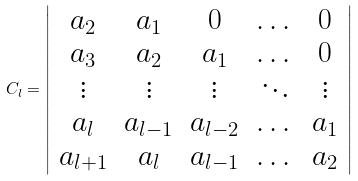<formula> <loc_0><loc_0><loc_500><loc_500>C _ { l } = \left | \begin{array} { c c c c c } a _ { 2 } & a _ { 1 } & 0 & \dots & 0 \\ a _ { 3 } & a _ { 2 } & a _ { 1 } & \dots & 0 \\ \vdots & \vdots & \vdots & \ddots & \vdots \\ a _ { l } & a _ { l - 1 } & a _ { l - 2 } & \dots & a _ { 1 } \\ a _ { l + 1 } & a _ { l } & a _ { l - 1 } & \dots & a _ { 2 } \end{array} \right |</formula> 